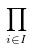<formula> <loc_0><loc_0><loc_500><loc_500>\prod _ { i \in I }</formula> 